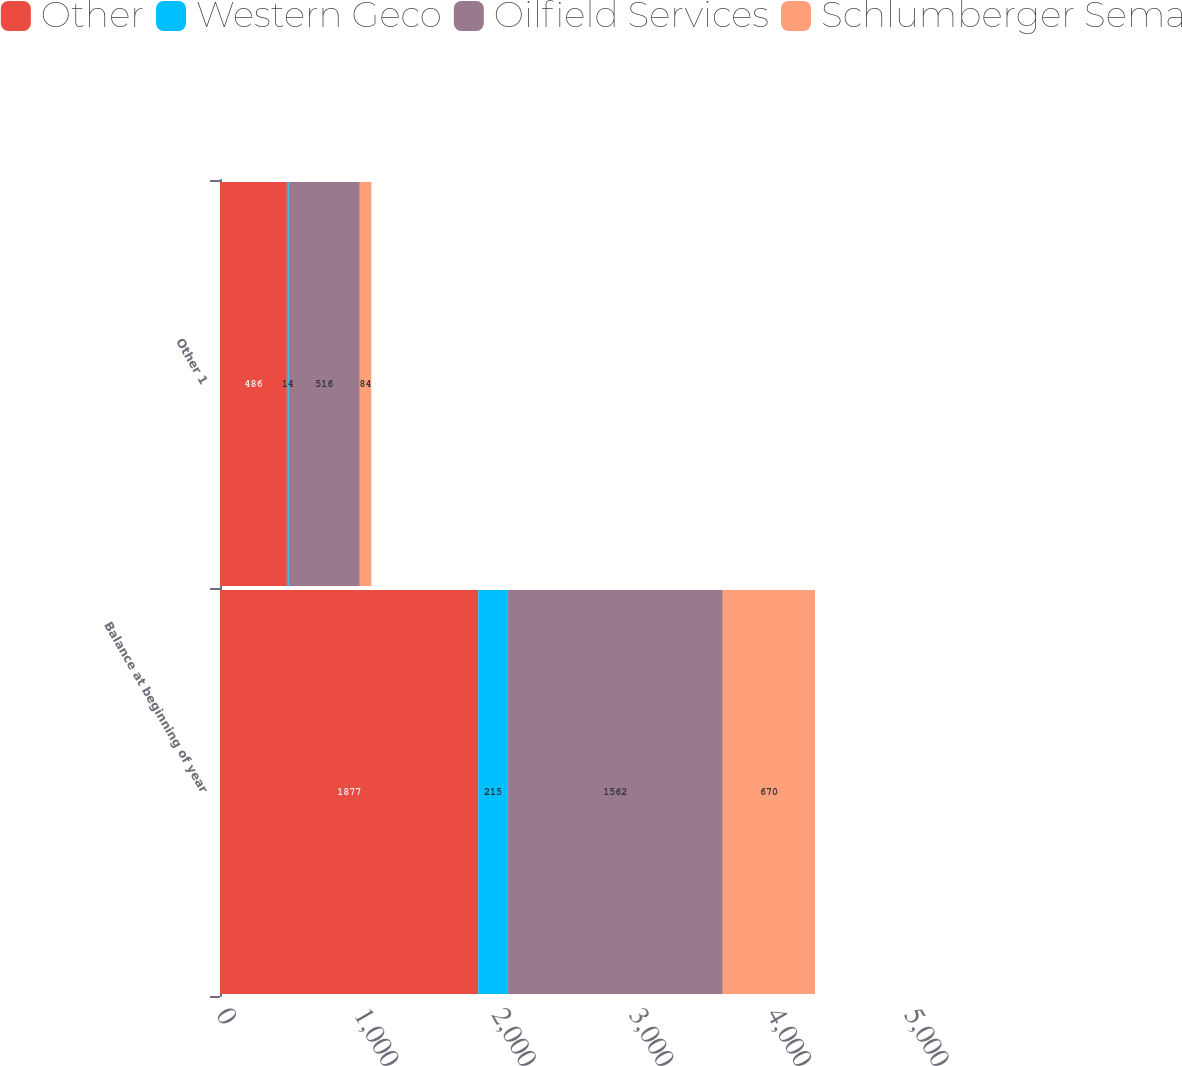Convert chart to OTSL. <chart><loc_0><loc_0><loc_500><loc_500><stacked_bar_chart><ecel><fcel>Balance at beginning of year<fcel>Other 1<nl><fcel>Other<fcel>1877<fcel>486<nl><fcel>Western Geco<fcel>215<fcel>14<nl><fcel>Oilfield Services<fcel>1562<fcel>516<nl><fcel>Schlumberger Sema<fcel>670<fcel>84<nl></chart> 